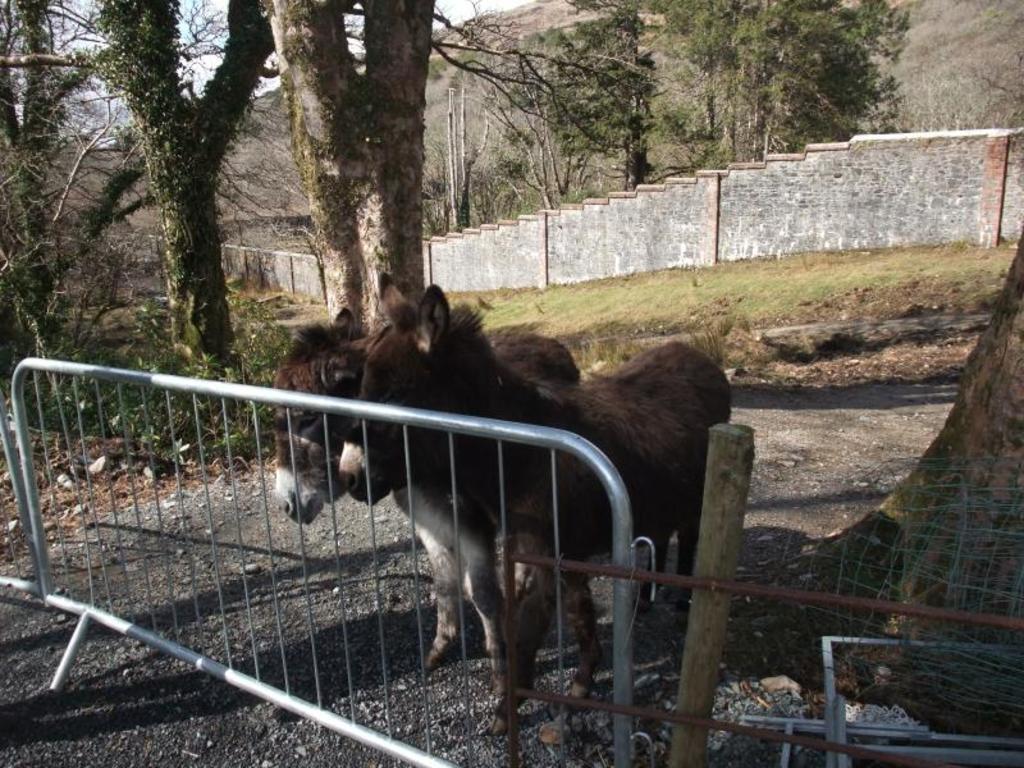Can you describe this image briefly? In this picture we can see some barricades and animals on the path. There are some tree trunks and few trees are visible in the background. We can see a compound wall from left to right. 